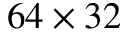<formula> <loc_0><loc_0><loc_500><loc_500>6 4 \times 3 2</formula> 